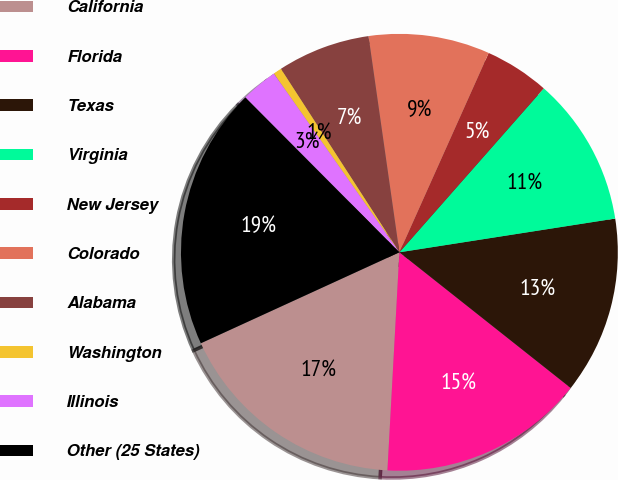Convert chart to OTSL. <chart><loc_0><loc_0><loc_500><loc_500><pie_chart><fcel>California<fcel>Florida<fcel>Texas<fcel>Virginia<fcel>New Jersey<fcel>Colorado<fcel>Alabama<fcel>Washington<fcel>Illinois<fcel>Other (25 States)<nl><fcel>17.29%<fcel>15.21%<fcel>13.13%<fcel>11.04%<fcel>4.79%<fcel>8.96%<fcel>6.87%<fcel>0.62%<fcel>2.71%<fcel>19.38%<nl></chart> 